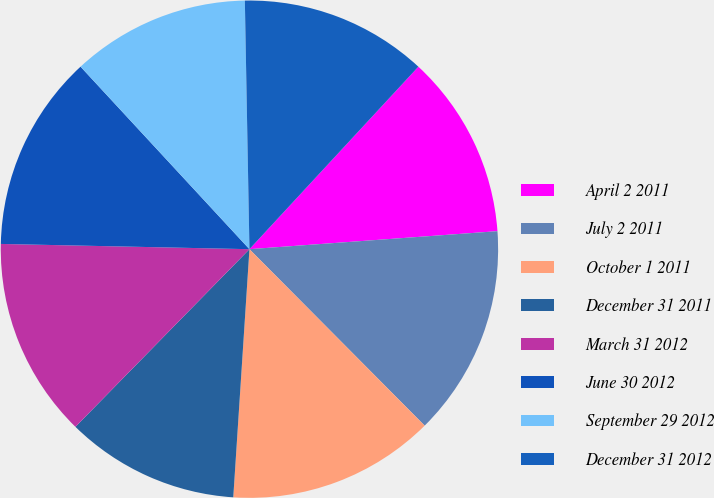Convert chart. <chart><loc_0><loc_0><loc_500><loc_500><pie_chart><fcel>April 2 2011<fcel>July 2 2011<fcel>October 1 2011<fcel>December 31 2011<fcel>March 31 2012<fcel>June 30 2012<fcel>September 29 2012<fcel>December 31 2012<nl><fcel>11.96%<fcel>13.71%<fcel>13.48%<fcel>11.3%<fcel>13.0%<fcel>12.78%<fcel>11.59%<fcel>12.18%<nl></chart> 